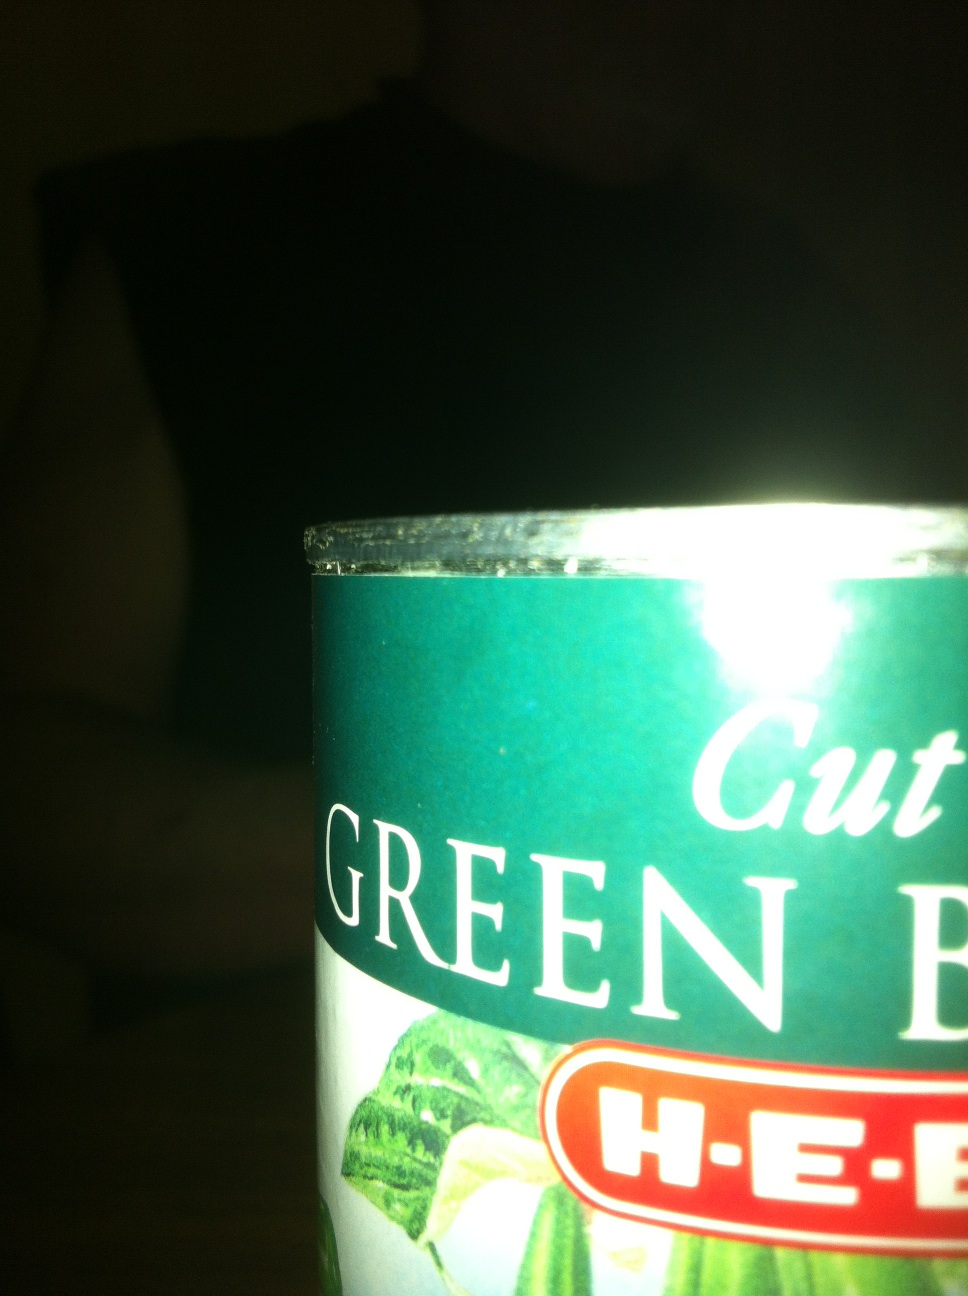What dishes are typically made with cut green beans? Cut green beans are quite versatile in cooking. They're commonly used in dishes like green bean casserole, often served at Thanksgiving. They can also be stir-fried, steamed, or added to soups, salads, and stews. 